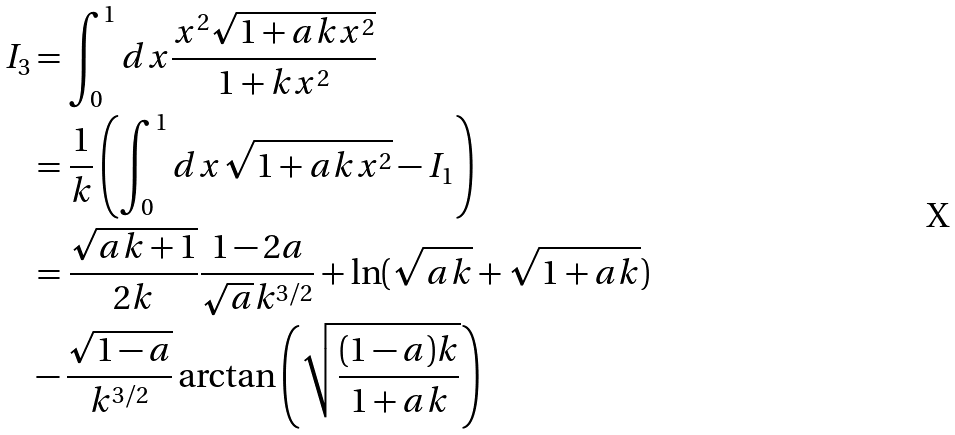Convert formula to latex. <formula><loc_0><loc_0><loc_500><loc_500>I _ { 3 } & = \int _ { 0 } ^ { 1 } d x \frac { x ^ { 2 } \sqrt { 1 + a k x ^ { 2 } } } { 1 + k x ^ { 2 } } \\ & = \frac { 1 } { k } \left ( \int _ { 0 } ^ { 1 } d x \sqrt { 1 + a k x ^ { 2 } } - I _ { 1 } \right ) \\ & = \frac { \sqrt { a k + 1 } } { 2 k } \frac { 1 - 2 a } { \sqrt { a } k ^ { 3 / 2 } } + \ln ( \sqrt { a k } + \sqrt { 1 + a k } ) \\ & - \frac { \sqrt { 1 - a } } { k ^ { 3 / 2 } } \arctan \left ( \sqrt { \frac { ( 1 - a ) k } { 1 + a k } } \right )</formula> 